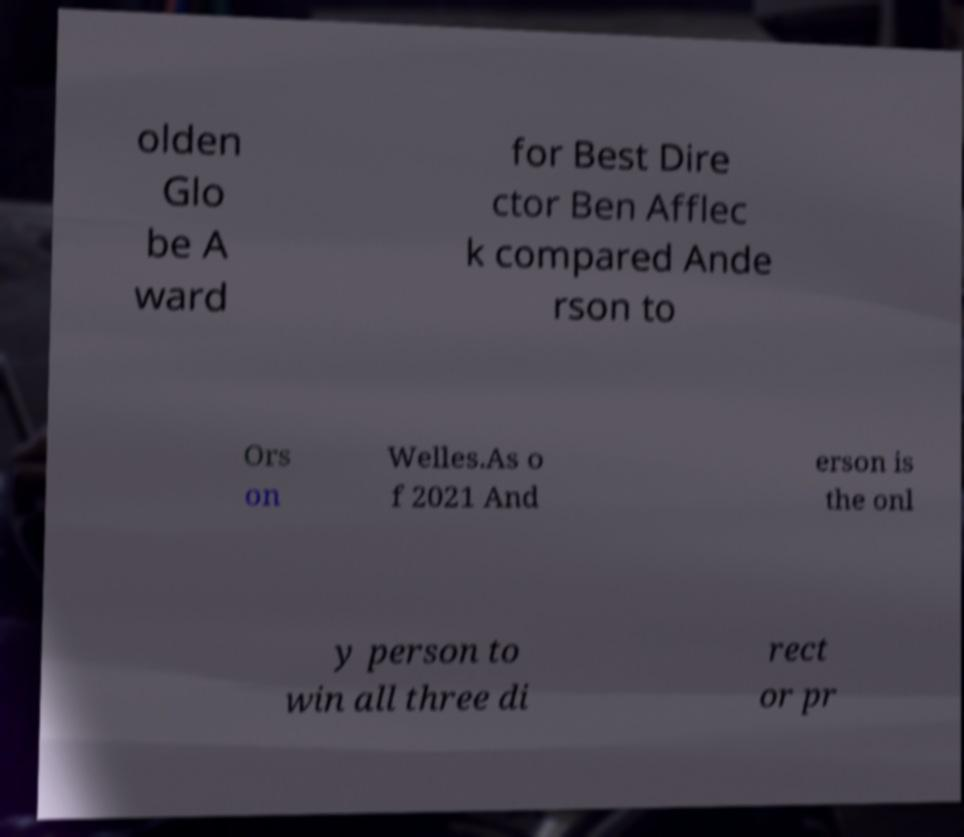Please read and relay the text visible in this image. What does it say? olden Glo be A ward for Best Dire ctor Ben Afflec k compared Ande rson to Ors on Welles.As o f 2021 And erson is the onl y person to win all three di rect or pr 